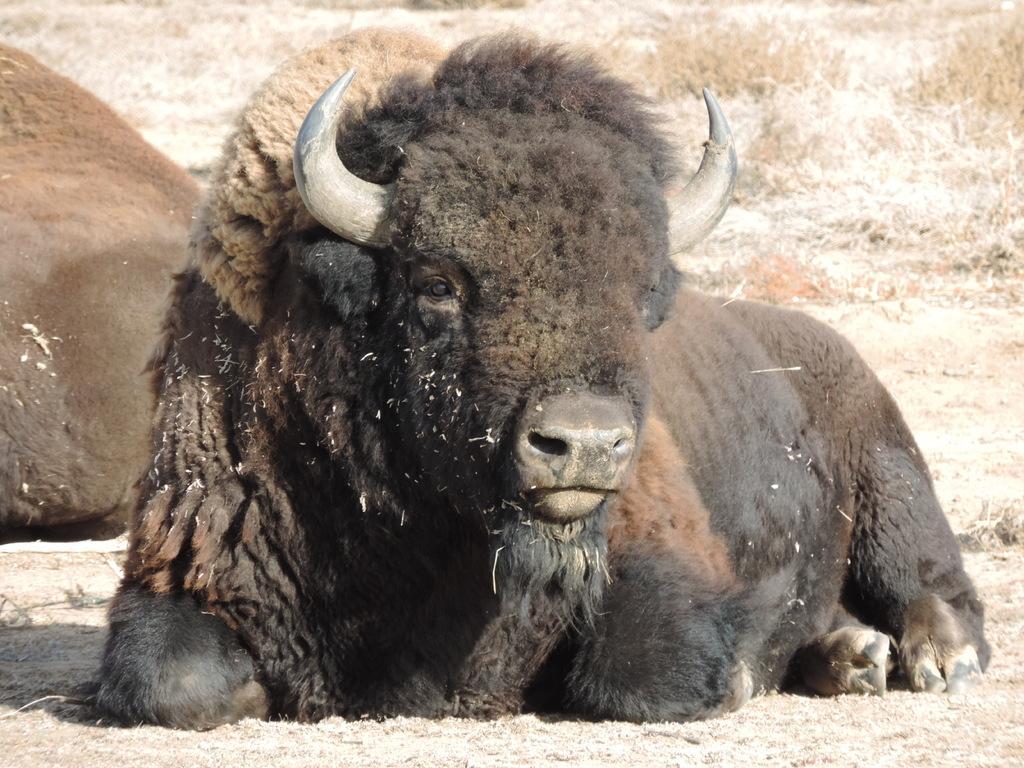How would you summarize this image in a sentence or two? In this picture we can see two bulls sitting on the ground, in the background we can see some grass. 